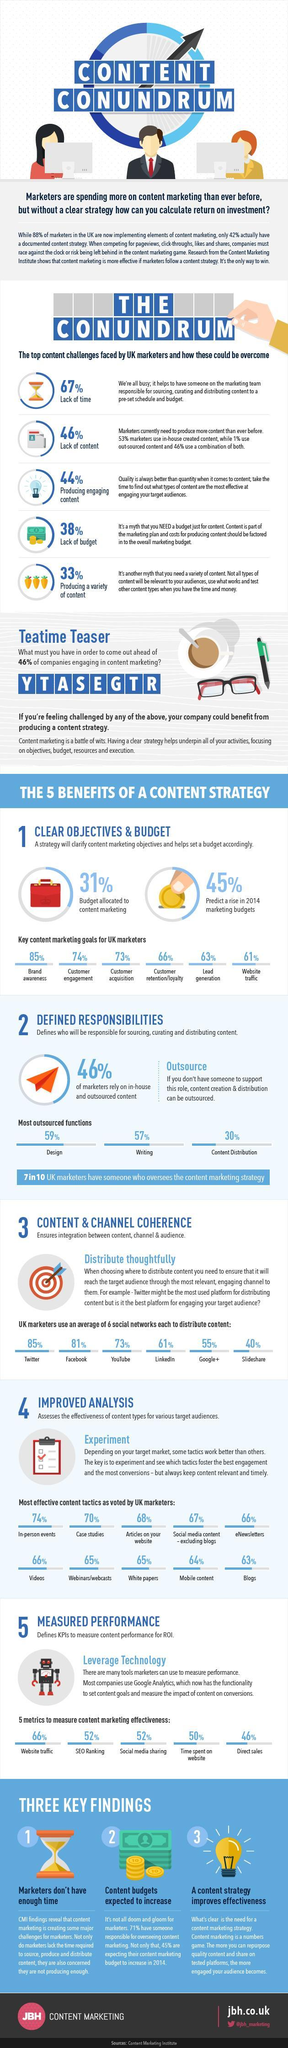What percentage of marketers complain of lack of content, 53%, 1%, or 46%?
Answer the question with a short phrase. 46% What  percentage of articles used as content for marketing in the UK? 68% Which function is the least outsourced among design, writing, and content distribution? content distribution Which content marketing goal has the second highest focus in terms of percentage value? Customer Engagement Which metric is used the least to measure marketing effectiveness? Direct Sales Which social media platform is used as the third highest platform to distribute content? Youtube How many content marketing goals are followed by UK Marketers? 6 Which content tactics are voted by 66% of the content marketers? eNewsletters, Videos 